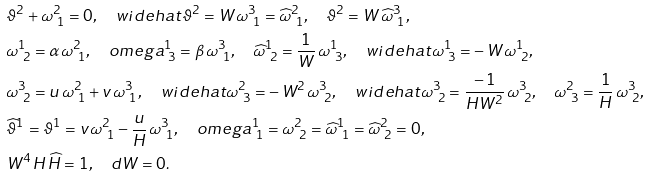<formula> <loc_0><loc_0><loc_500><loc_500>& \vartheta ^ { 2 } + \omega ^ { 2 } _ { \ 1 } = 0 , \quad w i d e h a t { \vartheta } ^ { 2 } = W \, \omega ^ { 3 } _ { \ 1 } = \widehat { \omega } ^ { 2 } _ { \ 1 } , \quad \vartheta ^ { 2 } = W \, \widehat { \omega } ^ { 3 } _ { \ 1 } , \\ & \omega ^ { 1 } _ { \ 2 } = \alpha \, \omega ^ { 2 } _ { \ 1 } , \quad o m e g a ^ { 1 } _ { \ 3 } = \beta \, \omega ^ { 3 } _ { \ 1 } , \quad \widehat { \omega } ^ { 1 } _ { \ 2 } = \frac { 1 } { W } \, \omega ^ { 1 } _ { \ 3 } , \quad w i d e h a t { \omega } ^ { 1 } _ { \ 3 } = - \, W \, \omega ^ { 1 } _ { \ 2 } , \\ & \omega ^ { 3 } _ { \ 2 } = u \, \omega ^ { 2 } _ { \ 1 } + v \, \omega ^ { 3 } _ { \ 1 } , \quad w i d e h a t { \omega } ^ { 2 } _ { \ 3 } = - \, W ^ { 2 } \, \omega ^ { 3 } _ { \ 2 } , \quad w i d e h a t { \omega } ^ { 3 } _ { \ 2 } = \frac { - \, 1 } { H W ^ { 2 } } \, \omega ^ { 3 } _ { \ 2 } , \quad \omega ^ { 2 } _ { \ 3 } = \frac { 1 } { H } \, \omega ^ { 3 } _ { \ 2 } , \\ & \widehat { \vartheta } ^ { 1 } = \vartheta ^ { 1 } = v \, \omega ^ { 2 } _ { \ 1 } - \frac { u } { H } \, \omega ^ { 3 } _ { \ 1 } , \quad o m e g a ^ { 1 } _ { \ 1 } = \omega ^ { 2 } _ { \ 2 } = \widehat { \omega } ^ { 1 } _ { \ 1 } = \widehat { \omega } ^ { 2 } _ { \ 2 } = 0 , \\ & W ^ { 4 } \, H \, \widehat { H } = 1 , \quad d W = 0 .</formula> 